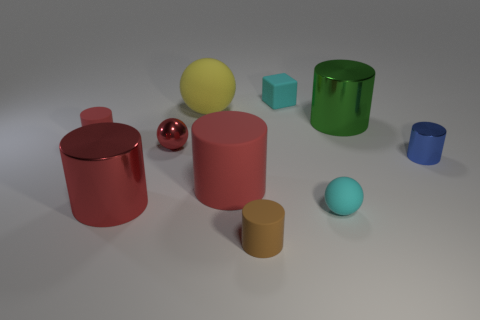What color is the small sphere on the left side of the brown object?
Ensure brevity in your answer.  Red. Are there the same number of yellow matte objects in front of the large green cylinder and small brown rubber cylinders?
Offer a very short reply. No. What number of other things are there of the same shape as the large red metal object?
Keep it short and to the point. 5. What number of yellow things are to the right of the small shiny cylinder?
Give a very brief answer. 0. There is a cylinder that is behind the small shiny sphere and to the left of the cyan cube; what is its size?
Ensure brevity in your answer.  Small. Are there any cyan metallic cylinders?
Your answer should be compact. No. What number of other things are the same size as the blue metallic object?
Your answer should be very brief. 5. Does the small rubber thing in front of the tiny rubber sphere have the same color as the small sphere that is on the right side of the brown cylinder?
Provide a succinct answer. No. The cyan object that is the same shape as the big yellow thing is what size?
Provide a short and direct response. Small. Is the material of the brown cylinder in front of the small metallic ball the same as the small sphere that is in front of the blue cylinder?
Your answer should be compact. Yes. 